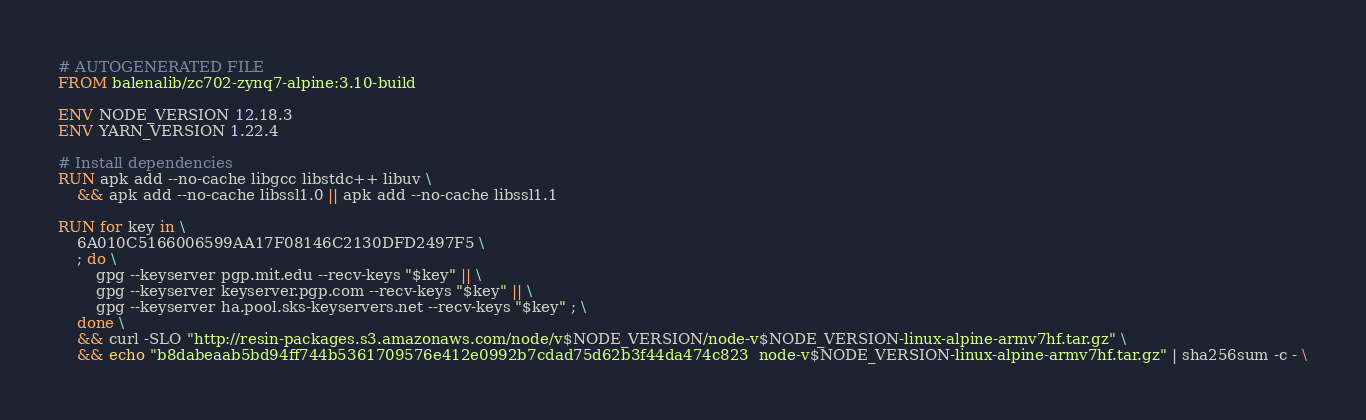<code> <loc_0><loc_0><loc_500><loc_500><_Dockerfile_># AUTOGENERATED FILE
FROM balenalib/zc702-zynq7-alpine:3.10-build

ENV NODE_VERSION 12.18.3
ENV YARN_VERSION 1.22.4

# Install dependencies
RUN apk add --no-cache libgcc libstdc++ libuv \
	&& apk add --no-cache libssl1.0 || apk add --no-cache libssl1.1

RUN for key in \
	6A010C5166006599AA17F08146C2130DFD2497F5 \
	; do \
		gpg --keyserver pgp.mit.edu --recv-keys "$key" || \
		gpg --keyserver keyserver.pgp.com --recv-keys "$key" || \
		gpg --keyserver ha.pool.sks-keyservers.net --recv-keys "$key" ; \
	done \
	&& curl -SLO "http://resin-packages.s3.amazonaws.com/node/v$NODE_VERSION/node-v$NODE_VERSION-linux-alpine-armv7hf.tar.gz" \
	&& echo "b8dabeaab5bd94ff744b5361709576e412e0992b7cdad75d62b3f44da474c823  node-v$NODE_VERSION-linux-alpine-armv7hf.tar.gz" | sha256sum -c - \</code> 